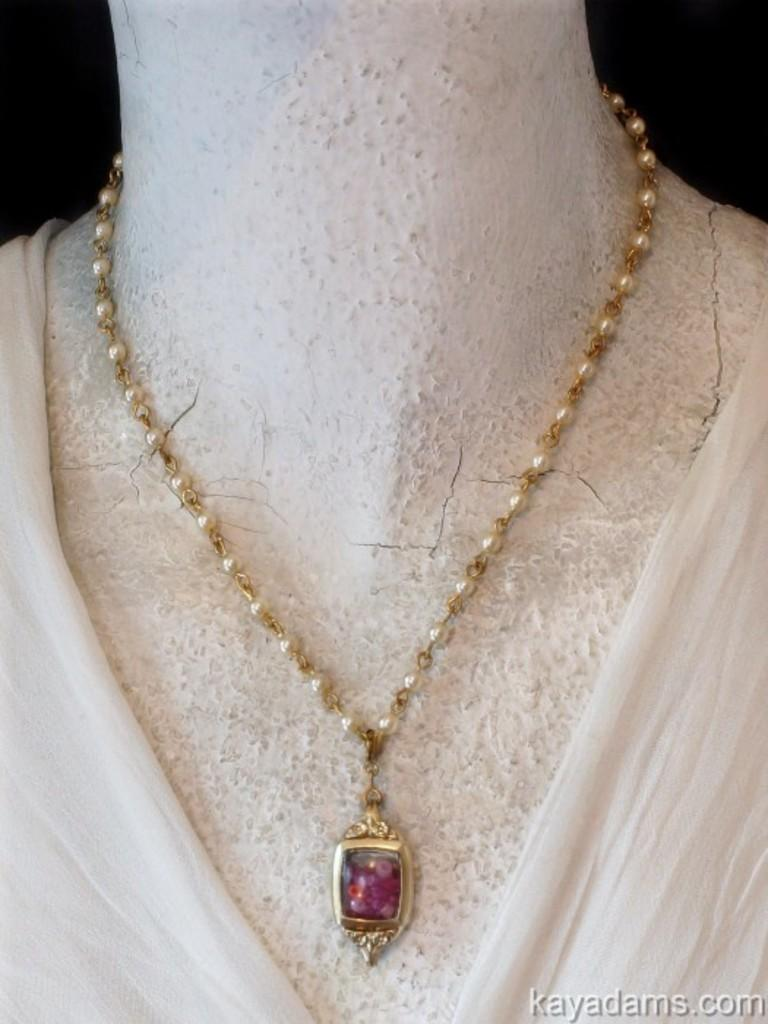What type of accessory is in the image? There is a necklace in the image. What type of clothing is on display in the image? There is a dress on a mannequin in the image. Is there any text present in the image? Yes, there is text visible on the image. How many toads are sitting on the dress in the image? There are no toads present in the image; it features a dress on a mannequin and a necklace. 